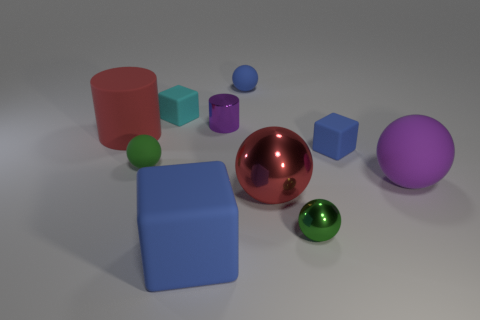How many things are either large purple matte spheres that are behind the large blue rubber block or large blue cubes?
Offer a terse response. 2. Is there a red matte thing of the same shape as the tiny purple thing?
Your answer should be compact. Yes. What shape is the green metal object that is the same size as the cyan matte thing?
Offer a very short reply. Sphere. There is a big red thing that is to the left of the small block left of the big blue cube that is on the right side of the green matte thing; what shape is it?
Your answer should be very brief. Cylinder. There is a small green rubber thing; is it the same shape as the tiny blue object behind the purple cylinder?
Keep it short and to the point. Yes. How many large objects are purple matte things or red shiny things?
Keep it short and to the point. 2. Is there a brown metallic block of the same size as the matte cylinder?
Offer a terse response. No. What is the color of the block in front of the purple thing that is in front of the large object to the left of the big rubber block?
Make the answer very short. Blue. Is the big block made of the same material as the cylinder right of the big rubber block?
Ensure brevity in your answer.  No. There is a blue object that is the same shape as the small green rubber thing; what size is it?
Give a very brief answer. Small. 